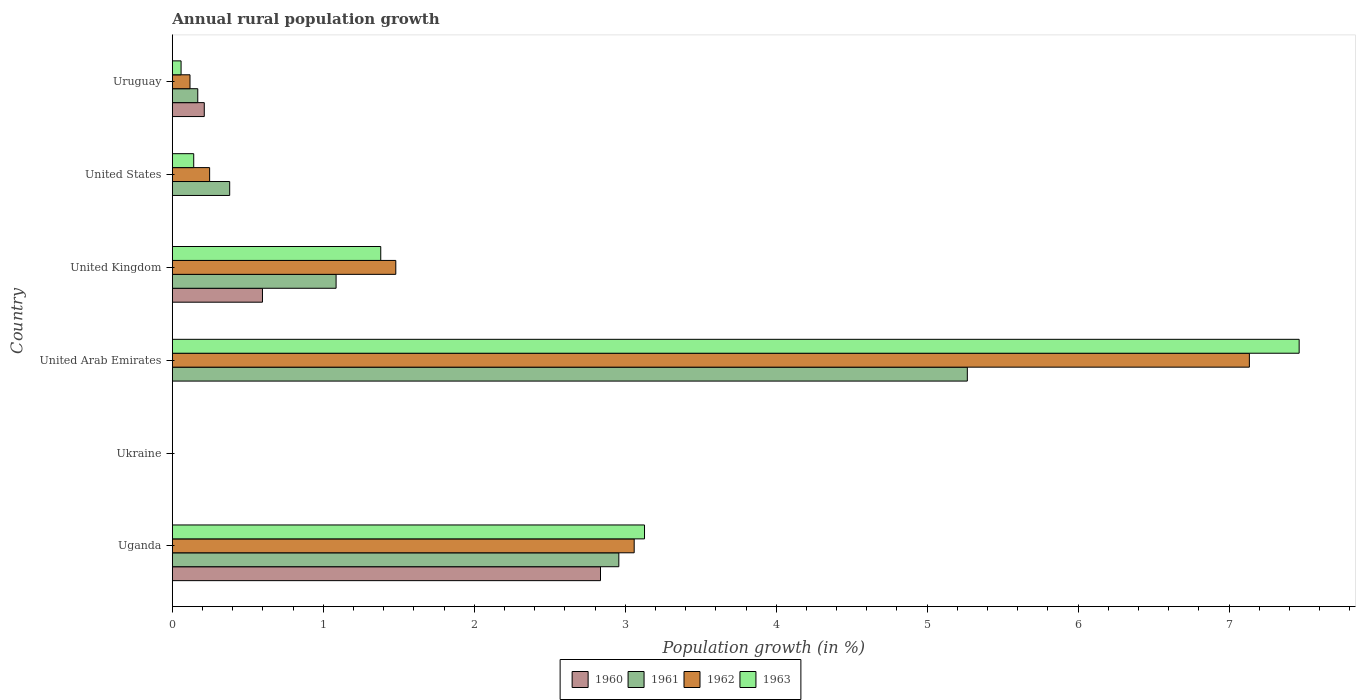How many different coloured bars are there?
Your response must be concise. 4. Are the number of bars per tick equal to the number of legend labels?
Provide a succinct answer. No. Are the number of bars on each tick of the Y-axis equal?
Keep it short and to the point. No. What is the label of the 2nd group of bars from the top?
Your answer should be very brief. United States. What is the percentage of rural population growth in 1963 in Uruguay?
Ensure brevity in your answer.  0.06. Across all countries, what is the maximum percentage of rural population growth in 1963?
Provide a short and direct response. 7.46. Across all countries, what is the minimum percentage of rural population growth in 1960?
Ensure brevity in your answer.  0. In which country was the percentage of rural population growth in 1961 maximum?
Your answer should be very brief. United Arab Emirates. What is the total percentage of rural population growth in 1963 in the graph?
Offer a very short reply. 12.17. What is the difference between the percentage of rural population growth in 1962 in United Arab Emirates and that in United States?
Make the answer very short. 6.89. What is the difference between the percentage of rural population growth in 1961 in United States and the percentage of rural population growth in 1962 in United Arab Emirates?
Your answer should be compact. -6.75. What is the average percentage of rural population growth in 1963 per country?
Keep it short and to the point. 2.03. What is the difference between the percentage of rural population growth in 1963 and percentage of rural population growth in 1960 in United Kingdom?
Provide a succinct answer. 0.78. In how many countries, is the percentage of rural population growth in 1962 greater than 3.6 %?
Keep it short and to the point. 1. What is the ratio of the percentage of rural population growth in 1963 in United Kingdom to that in Uruguay?
Your response must be concise. 23.87. What is the difference between the highest and the second highest percentage of rural population growth in 1960?
Make the answer very short. 2.24. What is the difference between the highest and the lowest percentage of rural population growth in 1961?
Your response must be concise. 5.27. How many bars are there?
Give a very brief answer. 18. Are the values on the major ticks of X-axis written in scientific E-notation?
Give a very brief answer. No. Does the graph contain any zero values?
Your answer should be compact. Yes. How many legend labels are there?
Provide a short and direct response. 4. How are the legend labels stacked?
Keep it short and to the point. Horizontal. What is the title of the graph?
Make the answer very short. Annual rural population growth. Does "1969" appear as one of the legend labels in the graph?
Your answer should be very brief. No. What is the label or title of the X-axis?
Provide a short and direct response. Population growth (in %). What is the Population growth (in %) in 1960 in Uganda?
Your answer should be very brief. 2.84. What is the Population growth (in %) in 1961 in Uganda?
Keep it short and to the point. 2.96. What is the Population growth (in %) in 1962 in Uganda?
Offer a terse response. 3.06. What is the Population growth (in %) of 1963 in Uganda?
Provide a short and direct response. 3.13. What is the Population growth (in %) in 1961 in Ukraine?
Make the answer very short. 0. What is the Population growth (in %) in 1962 in Ukraine?
Ensure brevity in your answer.  0. What is the Population growth (in %) of 1963 in Ukraine?
Make the answer very short. 0. What is the Population growth (in %) in 1961 in United Arab Emirates?
Give a very brief answer. 5.27. What is the Population growth (in %) of 1962 in United Arab Emirates?
Ensure brevity in your answer.  7.13. What is the Population growth (in %) of 1963 in United Arab Emirates?
Provide a succinct answer. 7.46. What is the Population growth (in %) of 1960 in United Kingdom?
Offer a terse response. 0.6. What is the Population growth (in %) of 1961 in United Kingdom?
Your response must be concise. 1.08. What is the Population growth (in %) in 1962 in United Kingdom?
Your response must be concise. 1.48. What is the Population growth (in %) of 1963 in United Kingdom?
Your answer should be compact. 1.38. What is the Population growth (in %) in 1960 in United States?
Give a very brief answer. 0. What is the Population growth (in %) of 1961 in United States?
Offer a terse response. 0.38. What is the Population growth (in %) in 1962 in United States?
Your answer should be compact. 0.25. What is the Population growth (in %) of 1963 in United States?
Keep it short and to the point. 0.14. What is the Population growth (in %) in 1960 in Uruguay?
Keep it short and to the point. 0.21. What is the Population growth (in %) in 1961 in Uruguay?
Your response must be concise. 0.17. What is the Population growth (in %) in 1962 in Uruguay?
Your answer should be compact. 0.12. What is the Population growth (in %) of 1963 in Uruguay?
Your response must be concise. 0.06. Across all countries, what is the maximum Population growth (in %) in 1960?
Ensure brevity in your answer.  2.84. Across all countries, what is the maximum Population growth (in %) in 1961?
Offer a terse response. 5.27. Across all countries, what is the maximum Population growth (in %) in 1962?
Provide a short and direct response. 7.13. Across all countries, what is the maximum Population growth (in %) of 1963?
Your answer should be compact. 7.46. Across all countries, what is the minimum Population growth (in %) in 1960?
Give a very brief answer. 0. Across all countries, what is the minimum Population growth (in %) of 1961?
Your answer should be compact. 0. What is the total Population growth (in %) of 1960 in the graph?
Give a very brief answer. 3.64. What is the total Population growth (in %) of 1961 in the graph?
Provide a short and direct response. 9.86. What is the total Population growth (in %) of 1962 in the graph?
Provide a short and direct response. 12.04. What is the total Population growth (in %) in 1963 in the graph?
Offer a terse response. 12.17. What is the difference between the Population growth (in %) of 1961 in Uganda and that in United Arab Emirates?
Offer a very short reply. -2.31. What is the difference between the Population growth (in %) in 1962 in Uganda and that in United Arab Emirates?
Keep it short and to the point. -4.08. What is the difference between the Population growth (in %) in 1963 in Uganda and that in United Arab Emirates?
Ensure brevity in your answer.  -4.34. What is the difference between the Population growth (in %) of 1960 in Uganda and that in United Kingdom?
Provide a succinct answer. 2.24. What is the difference between the Population growth (in %) in 1961 in Uganda and that in United Kingdom?
Make the answer very short. 1.87. What is the difference between the Population growth (in %) in 1962 in Uganda and that in United Kingdom?
Offer a terse response. 1.58. What is the difference between the Population growth (in %) of 1963 in Uganda and that in United Kingdom?
Make the answer very short. 1.75. What is the difference between the Population growth (in %) of 1961 in Uganda and that in United States?
Ensure brevity in your answer.  2.58. What is the difference between the Population growth (in %) in 1962 in Uganda and that in United States?
Provide a succinct answer. 2.81. What is the difference between the Population growth (in %) of 1963 in Uganda and that in United States?
Your answer should be compact. 2.99. What is the difference between the Population growth (in %) of 1960 in Uganda and that in Uruguay?
Your answer should be very brief. 2.62. What is the difference between the Population growth (in %) of 1961 in Uganda and that in Uruguay?
Your answer should be compact. 2.79. What is the difference between the Population growth (in %) of 1962 in Uganda and that in Uruguay?
Your answer should be compact. 2.94. What is the difference between the Population growth (in %) of 1963 in Uganda and that in Uruguay?
Offer a terse response. 3.07. What is the difference between the Population growth (in %) in 1961 in United Arab Emirates and that in United Kingdom?
Keep it short and to the point. 4.18. What is the difference between the Population growth (in %) of 1962 in United Arab Emirates and that in United Kingdom?
Your answer should be very brief. 5.65. What is the difference between the Population growth (in %) in 1963 in United Arab Emirates and that in United Kingdom?
Give a very brief answer. 6.08. What is the difference between the Population growth (in %) in 1961 in United Arab Emirates and that in United States?
Provide a succinct answer. 4.89. What is the difference between the Population growth (in %) in 1962 in United Arab Emirates and that in United States?
Give a very brief answer. 6.89. What is the difference between the Population growth (in %) in 1963 in United Arab Emirates and that in United States?
Provide a succinct answer. 7.32. What is the difference between the Population growth (in %) in 1961 in United Arab Emirates and that in Uruguay?
Ensure brevity in your answer.  5.1. What is the difference between the Population growth (in %) in 1962 in United Arab Emirates and that in Uruguay?
Your response must be concise. 7.02. What is the difference between the Population growth (in %) in 1963 in United Arab Emirates and that in Uruguay?
Ensure brevity in your answer.  7.41. What is the difference between the Population growth (in %) in 1961 in United Kingdom and that in United States?
Provide a succinct answer. 0.7. What is the difference between the Population growth (in %) of 1962 in United Kingdom and that in United States?
Your answer should be compact. 1.23. What is the difference between the Population growth (in %) in 1963 in United Kingdom and that in United States?
Your answer should be very brief. 1.24. What is the difference between the Population growth (in %) of 1960 in United Kingdom and that in Uruguay?
Keep it short and to the point. 0.39. What is the difference between the Population growth (in %) in 1961 in United Kingdom and that in Uruguay?
Make the answer very short. 0.92. What is the difference between the Population growth (in %) of 1962 in United Kingdom and that in Uruguay?
Provide a short and direct response. 1.36. What is the difference between the Population growth (in %) of 1963 in United Kingdom and that in Uruguay?
Offer a terse response. 1.32. What is the difference between the Population growth (in %) of 1961 in United States and that in Uruguay?
Your answer should be compact. 0.21. What is the difference between the Population growth (in %) in 1962 in United States and that in Uruguay?
Keep it short and to the point. 0.13. What is the difference between the Population growth (in %) in 1963 in United States and that in Uruguay?
Your answer should be compact. 0.08. What is the difference between the Population growth (in %) of 1960 in Uganda and the Population growth (in %) of 1961 in United Arab Emirates?
Your answer should be compact. -2.43. What is the difference between the Population growth (in %) of 1960 in Uganda and the Population growth (in %) of 1962 in United Arab Emirates?
Make the answer very short. -4.3. What is the difference between the Population growth (in %) of 1960 in Uganda and the Population growth (in %) of 1963 in United Arab Emirates?
Ensure brevity in your answer.  -4.63. What is the difference between the Population growth (in %) in 1961 in Uganda and the Population growth (in %) in 1962 in United Arab Emirates?
Offer a very short reply. -4.18. What is the difference between the Population growth (in %) in 1961 in Uganda and the Population growth (in %) in 1963 in United Arab Emirates?
Provide a short and direct response. -4.51. What is the difference between the Population growth (in %) of 1962 in Uganda and the Population growth (in %) of 1963 in United Arab Emirates?
Provide a succinct answer. -4.4. What is the difference between the Population growth (in %) in 1960 in Uganda and the Population growth (in %) in 1961 in United Kingdom?
Offer a terse response. 1.75. What is the difference between the Population growth (in %) of 1960 in Uganda and the Population growth (in %) of 1962 in United Kingdom?
Ensure brevity in your answer.  1.36. What is the difference between the Population growth (in %) in 1960 in Uganda and the Population growth (in %) in 1963 in United Kingdom?
Your answer should be very brief. 1.46. What is the difference between the Population growth (in %) in 1961 in Uganda and the Population growth (in %) in 1962 in United Kingdom?
Offer a very short reply. 1.48. What is the difference between the Population growth (in %) of 1961 in Uganda and the Population growth (in %) of 1963 in United Kingdom?
Provide a succinct answer. 1.58. What is the difference between the Population growth (in %) of 1962 in Uganda and the Population growth (in %) of 1963 in United Kingdom?
Ensure brevity in your answer.  1.68. What is the difference between the Population growth (in %) of 1960 in Uganda and the Population growth (in %) of 1961 in United States?
Keep it short and to the point. 2.46. What is the difference between the Population growth (in %) of 1960 in Uganda and the Population growth (in %) of 1962 in United States?
Ensure brevity in your answer.  2.59. What is the difference between the Population growth (in %) of 1960 in Uganda and the Population growth (in %) of 1963 in United States?
Ensure brevity in your answer.  2.69. What is the difference between the Population growth (in %) of 1961 in Uganda and the Population growth (in %) of 1962 in United States?
Ensure brevity in your answer.  2.71. What is the difference between the Population growth (in %) in 1961 in Uganda and the Population growth (in %) in 1963 in United States?
Make the answer very short. 2.82. What is the difference between the Population growth (in %) of 1962 in Uganda and the Population growth (in %) of 1963 in United States?
Provide a short and direct response. 2.92. What is the difference between the Population growth (in %) of 1960 in Uganda and the Population growth (in %) of 1961 in Uruguay?
Give a very brief answer. 2.67. What is the difference between the Population growth (in %) in 1960 in Uganda and the Population growth (in %) in 1962 in Uruguay?
Provide a succinct answer. 2.72. What is the difference between the Population growth (in %) of 1960 in Uganda and the Population growth (in %) of 1963 in Uruguay?
Ensure brevity in your answer.  2.78. What is the difference between the Population growth (in %) of 1961 in Uganda and the Population growth (in %) of 1962 in Uruguay?
Keep it short and to the point. 2.84. What is the difference between the Population growth (in %) of 1961 in Uganda and the Population growth (in %) of 1963 in Uruguay?
Provide a succinct answer. 2.9. What is the difference between the Population growth (in %) of 1962 in Uganda and the Population growth (in %) of 1963 in Uruguay?
Your answer should be compact. 3. What is the difference between the Population growth (in %) in 1961 in United Arab Emirates and the Population growth (in %) in 1962 in United Kingdom?
Offer a very short reply. 3.79. What is the difference between the Population growth (in %) in 1961 in United Arab Emirates and the Population growth (in %) in 1963 in United Kingdom?
Offer a terse response. 3.89. What is the difference between the Population growth (in %) in 1962 in United Arab Emirates and the Population growth (in %) in 1963 in United Kingdom?
Ensure brevity in your answer.  5.75. What is the difference between the Population growth (in %) in 1961 in United Arab Emirates and the Population growth (in %) in 1962 in United States?
Give a very brief answer. 5.02. What is the difference between the Population growth (in %) of 1961 in United Arab Emirates and the Population growth (in %) of 1963 in United States?
Ensure brevity in your answer.  5.12. What is the difference between the Population growth (in %) of 1962 in United Arab Emirates and the Population growth (in %) of 1963 in United States?
Provide a succinct answer. 6.99. What is the difference between the Population growth (in %) of 1961 in United Arab Emirates and the Population growth (in %) of 1962 in Uruguay?
Offer a terse response. 5.15. What is the difference between the Population growth (in %) of 1961 in United Arab Emirates and the Population growth (in %) of 1963 in Uruguay?
Make the answer very short. 5.21. What is the difference between the Population growth (in %) of 1962 in United Arab Emirates and the Population growth (in %) of 1963 in Uruguay?
Keep it short and to the point. 7.08. What is the difference between the Population growth (in %) of 1960 in United Kingdom and the Population growth (in %) of 1961 in United States?
Ensure brevity in your answer.  0.22. What is the difference between the Population growth (in %) of 1960 in United Kingdom and the Population growth (in %) of 1962 in United States?
Offer a very short reply. 0.35. What is the difference between the Population growth (in %) in 1960 in United Kingdom and the Population growth (in %) in 1963 in United States?
Give a very brief answer. 0.46. What is the difference between the Population growth (in %) in 1961 in United Kingdom and the Population growth (in %) in 1962 in United States?
Offer a very short reply. 0.84. What is the difference between the Population growth (in %) of 1961 in United Kingdom and the Population growth (in %) of 1963 in United States?
Ensure brevity in your answer.  0.94. What is the difference between the Population growth (in %) in 1962 in United Kingdom and the Population growth (in %) in 1963 in United States?
Provide a short and direct response. 1.34. What is the difference between the Population growth (in %) in 1960 in United Kingdom and the Population growth (in %) in 1961 in Uruguay?
Your answer should be compact. 0.43. What is the difference between the Population growth (in %) in 1960 in United Kingdom and the Population growth (in %) in 1962 in Uruguay?
Make the answer very short. 0.48. What is the difference between the Population growth (in %) of 1960 in United Kingdom and the Population growth (in %) of 1963 in Uruguay?
Your response must be concise. 0.54. What is the difference between the Population growth (in %) in 1961 in United Kingdom and the Population growth (in %) in 1962 in Uruguay?
Give a very brief answer. 0.97. What is the difference between the Population growth (in %) of 1961 in United Kingdom and the Population growth (in %) of 1963 in Uruguay?
Provide a succinct answer. 1.03. What is the difference between the Population growth (in %) in 1962 in United Kingdom and the Population growth (in %) in 1963 in Uruguay?
Offer a very short reply. 1.42. What is the difference between the Population growth (in %) of 1961 in United States and the Population growth (in %) of 1962 in Uruguay?
Provide a short and direct response. 0.26. What is the difference between the Population growth (in %) of 1961 in United States and the Population growth (in %) of 1963 in Uruguay?
Offer a terse response. 0.32. What is the difference between the Population growth (in %) in 1962 in United States and the Population growth (in %) in 1963 in Uruguay?
Ensure brevity in your answer.  0.19. What is the average Population growth (in %) of 1960 per country?
Provide a short and direct response. 0.61. What is the average Population growth (in %) of 1961 per country?
Give a very brief answer. 1.64. What is the average Population growth (in %) of 1962 per country?
Your answer should be very brief. 2.01. What is the average Population growth (in %) of 1963 per country?
Offer a terse response. 2.03. What is the difference between the Population growth (in %) in 1960 and Population growth (in %) in 1961 in Uganda?
Provide a short and direct response. -0.12. What is the difference between the Population growth (in %) of 1960 and Population growth (in %) of 1962 in Uganda?
Provide a short and direct response. -0.22. What is the difference between the Population growth (in %) in 1960 and Population growth (in %) in 1963 in Uganda?
Provide a succinct answer. -0.29. What is the difference between the Population growth (in %) of 1961 and Population growth (in %) of 1962 in Uganda?
Keep it short and to the point. -0.1. What is the difference between the Population growth (in %) in 1961 and Population growth (in %) in 1963 in Uganda?
Ensure brevity in your answer.  -0.17. What is the difference between the Population growth (in %) of 1962 and Population growth (in %) of 1963 in Uganda?
Ensure brevity in your answer.  -0.07. What is the difference between the Population growth (in %) of 1961 and Population growth (in %) of 1962 in United Arab Emirates?
Your answer should be compact. -1.87. What is the difference between the Population growth (in %) in 1961 and Population growth (in %) in 1963 in United Arab Emirates?
Provide a succinct answer. -2.2. What is the difference between the Population growth (in %) in 1962 and Population growth (in %) in 1963 in United Arab Emirates?
Offer a very short reply. -0.33. What is the difference between the Population growth (in %) in 1960 and Population growth (in %) in 1961 in United Kingdom?
Your answer should be compact. -0.49. What is the difference between the Population growth (in %) of 1960 and Population growth (in %) of 1962 in United Kingdom?
Provide a short and direct response. -0.88. What is the difference between the Population growth (in %) of 1960 and Population growth (in %) of 1963 in United Kingdom?
Make the answer very short. -0.78. What is the difference between the Population growth (in %) of 1961 and Population growth (in %) of 1962 in United Kingdom?
Keep it short and to the point. -0.4. What is the difference between the Population growth (in %) in 1961 and Population growth (in %) in 1963 in United Kingdom?
Offer a terse response. -0.3. What is the difference between the Population growth (in %) in 1962 and Population growth (in %) in 1963 in United Kingdom?
Ensure brevity in your answer.  0.1. What is the difference between the Population growth (in %) of 1961 and Population growth (in %) of 1962 in United States?
Offer a terse response. 0.13. What is the difference between the Population growth (in %) in 1961 and Population growth (in %) in 1963 in United States?
Your response must be concise. 0.24. What is the difference between the Population growth (in %) in 1962 and Population growth (in %) in 1963 in United States?
Offer a very short reply. 0.11. What is the difference between the Population growth (in %) of 1960 and Population growth (in %) of 1961 in Uruguay?
Your response must be concise. 0.04. What is the difference between the Population growth (in %) of 1960 and Population growth (in %) of 1962 in Uruguay?
Your answer should be compact. 0.09. What is the difference between the Population growth (in %) in 1960 and Population growth (in %) in 1963 in Uruguay?
Your response must be concise. 0.15. What is the difference between the Population growth (in %) in 1961 and Population growth (in %) in 1962 in Uruguay?
Offer a terse response. 0.05. What is the difference between the Population growth (in %) in 1961 and Population growth (in %) in 1963 in Uruguay?
Offer a terse response. 0.11. What is the difference between the Population growth (in %) in 1962 and Population growth (in %) in 1963 in Uruguay?
Give a very brief answer. 0.06. What is the ratio of the Population growth (in %) of 1961 in Uganda to that in United Arab Emirates?
Provide a succinct answer. 0.56. What is the ratio of the Population growth (in %) of 1962 in Uganda to that in United Arab Emirates?
Ensure brevity in your answer.  0.43. What is the ratio of the Population growth (in %) in 1963 in Uganda to that in United Arab Emirates?
Make the answer very short. 0.42. What is the ratio of the Population growth (in %) in 1960 in Uganda to that in United Kingdom?
Your answer should be compact. 4.75. What is the ratio of the Population growth (in %) of 1961 in Uganda to that in United Kingdom?
Your answer should be compact. 2.73. What is the ratio of the Population growth (in %) in 1962 in Uganda to that in United Kingdom?
Ensure brevity in your answer.  2.07. What is the ratio of the Population growth (in %) in 1963 in Uganda to that in United Kingdom?
Offer a terse response. 2.27. What is the ratio of the Population growth (in %) in 1961 in Uganda to that in United States?
Provide a short and direct response. 7.79. What is the ratio of the Population growth (in %) of 1962 in Uganda to that in United States?
Your response must be concise. 12.39. What is the ratio of the Population growth (in %) of 1963 in Uganda to that in United States?
Offer a terse response. 22.09. What is the ratio of the Population growth (in %) of 1960 in Uganda to that in Uruguay?
Offer a very short reply. 13.41. What is the ratio of the Population growth (in %) in 1961 in Uganda to that in Uruguay?
Give a very brief answer. 17.57. What is the ratio of the Population growth (in %) of 1962 in Uganda to that in Uruguay?
Give a very brief answer. 26.16. What is the ratio of the Population growth (in %) in 1963 in Uganda to that in Uruguay?
Your answer should be very brief. 54.08. What is the ratio of the Population growth (in %) in 1961 in United Arab Emirates to that in United Kingdom?
Ensure brevity in your answer.  4.85. What is the ratio of the Population growth (in %) of 1962 in United Arab Emirates to that in United Kingdom?
Ensure brevity in your answer.  4.82. What is the ratio of the Population growth (in %) in 1963 in United Arab Emirates to that in United Kingdom?
Ensure brevity in your answer.  5.41. What is the ratio of the Population growth (in %) of 1961 in United Arab Emirates to that in United States?
Make the answer very short. 13.87. What is the ratio of the Population growth (in %) in 1962 in United Arab Emirates to that in United States?
Ensure brevity in your answer.  28.89. What is the ratio of the Population growth (in %) in 1963 in United Arab Emirates to that in United States?
Your answer should be compact. 52.72. What is the ratio of the Population growth (in %) of 1961 in United Arab Emirates to that in Uruguay?
Offer a terse response. 31.29. What is the ratio of the Population growth (in %) of 1962 in United Arab Emirates to that in Uruguay?
Your response must be concise. 61. What is the ratio of the Population growth (in %) in 1963 in United Arab Emirates to that in Uruguay?
Provide a short and direct response. 129.07. What is the ratio of the Population growth (in %) in 1961 in United Kingdom to that in United States?
Offer a very short reply. 2.86. What is the ratio of the Population growth (in %) of 1962 in United Kingdom to that in United States?
Give a very brief answer. 5.99. What is the ratio of the Population growth (in %) of 1963 in United Kingdom to that in United States?
Provide a short and direct response. 9.75. What is the ratio of the Population growth (in %) in 1960 in United Kingdom to that in Uruguay?
Offer a terse response. 2.82. What is the ratio of the Population growth (in %) of 1961 in United Kingdom to that in Uruguay?
Keep it short and to the point. 6.44. What is the ratio of the Population growth (in %) in 1962 in United Kingdom to that in Uruguay?
Ensure brevity in your answer.  12.66. What is the ratio of the Population growth (in %) of 1963 in United Kingdom to that in Uruguay?
Offer a very short reply. 23.87. What is the ratio of the Population growth (in %) in 1961 in United States to that in Uruguay?
Keep it short and to the point. 2.26. What is the ratio of the Population growth (in %) in 1962 in United States to that in Uruguay?
Offer a terse response. 2.11. What is the ratio of the Population growth (in %) of 1963 in United States to that in Uruguay?
Offer a terse response. 2.45. What is the difference between the highest and the second highest Population growth (in %) in 1960?
Give a very brief answer. 2.24. What is the difference between the highest and the second highest Population growth (in %) of 1961?
Keep it short and to the point. 2.31. What is the difference between the highest and the second highest Population growth (in %) in 1962?
Ensure brevity in your answer.  4.08. What is the difference between the highest and the second highest Population growth (in %) in 1963?
Ensure brevity in your answer.  4.34. What is the difference between the highest and the lowest Population growth (in %) in 1960?
Your answer should be very brief. 2.84. What is the difference between the highest and the lowest Population growth (in %) in 1961?
Your answer should be very brief. 5.27. What is the difference between the highest and the lowest Population growth (in %) in 1962?
Keep it short and to the point. 7.13. What is the difference between the highest and the lowest Population growth (in %) of 1963?
Your answer should be compact. 7.46. 